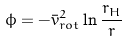<formula> <loc_0><loc_0><loc_500><loc_500>\phi = - \bar { v } _ { r o t } ^ { 2 } \ln \frac { r _ { H } } { r }</formula> 